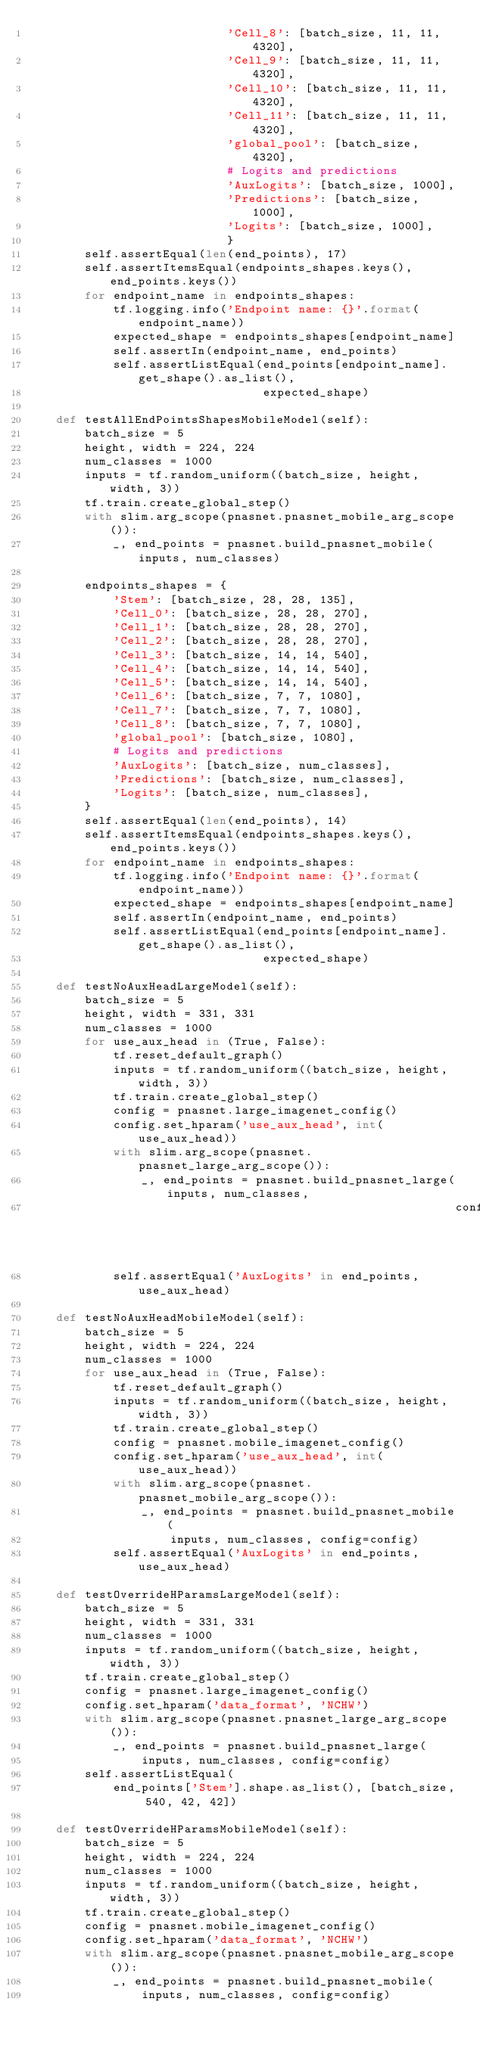Convert code to text. <code><loc_0><loc_0><loc_500><loc_500><_Python_>                            'Cell_8': [batch_size, 11, 11, 4320],
                            'Cell_9': [batch_size, 11, 11, 4320],
                            'Cell_10': [batch_size, 11, 11, 4320],
                            'Cell_11': [batch_size, 11, 11, 4320],
                            'global_pool': [batch_size, 4320],
                            # Logits and predictions
                            'AuxLogits': [batch_size, 1000],
                            'Predictions': [batch_size, 1000],
                            'Logits': [batch_size, 1000],
                            }
        self.assertEqual(len(end_points), 17)
        self.assertItemsEqual(endpoints_shapes.keys(), end_points.keys())
        for endpoint_name in endpoints_shapes:
            tf.logging.info('Endpoint name: {}'.format(endpoint_name))
            expected_shape = endpoints_shapes[endpoint_name]
            self.assertIn(endpoint_name, end_points)
            self.assertListEqual(end_points[endpoint_name].get_shape().as_list(),
                                 expected_shape)

    def testAllEndPointsShapesMobileModel(self):
        batch_size = 5
        height, width = 224, 224
        num_classes = 1000
        inputs = tf.random_uniform((batch_size, height, width, 3))
        tf.train.create_global_step()
        with slim.arg_scope(pnasnet.pnasnet_mobile_arg_scope()):
            _, end_points = pnasnet.build_pnasnet_mobile(inputs, num_classes)

        endpoints_shapes = {
            'Stem': [batch_size, 28, 28, 135],
            'Cell_0': [batch_size, 28, 28, 270],
            'Cell_1': [batch_size, 28, 28, 270],
            'Cell_2': [batch_size, 28, 28, 270],
            'Cell_3': [batch_size, 14, 14, 540],
            'Cell_4': [batch_size, 14, 14, 540],
            'Cell_5': [batch_size, 14, 14, 540],
            'Cell_6': [batch_size, 7, 7, 1080],
            'Cell_7': [batch_size, 7, 7, 1080],
            'Cell_8': [batch_size, 7, 7, 1080],
            'global_pool': [batch_size, 1080],
            # Logits and predictions
            'AuxLogits': [batch_size, num_classes],
            'Predictions': [batch_size, num_classes],
            'Logits': [batch_size, num_classes],
        }
        self.assertEqual(len(end_points), 14)
        self.assertItemsEqual(endpoints_shapes.keys(), end_points.keys())
        for endpoint_name in endpoints_shapes:
            tf.logging.info('Endpoint name: {}'.format(endpoint_name))
            expected_shape = endpoints_shapes[endpoint_name]
            self.assertIn(endpoint_name, end_points)
            self.assertListEqual(end_points[endpoint_name].get_shape().as_list(),
                                 expected_shape)

    def testNoAuxHeadLargeModel(self):
        batch_size = 5
        height, width = 331, 331
        num_classes = 1000
        for use_aux_head in (True, False):
            tf.reset_default_graph()
            inputs = tf.random_uniform((batch_size, height, width, 3))
            tf.train.create_global_step()
            config = pnasnet.large_imagenet_config()
            config.set_hparam('use_aux_head', int(use_aux_head))
            with slim.arg_scope(pnasnet.pnasnet_large_arg_scope()):
                _, end_points = pnasnet.build_pnasnet_large(inputs, num_classes,
                                                            config=config)
            self.assertEqual('AuxLogits' in end_points, use_aux_head)

    def testNoAuxHeadMobileModel(self):
        batch_size = 5
        height, width = 224, 224
        num_classes = 1000
        for use_aux_head in (True, False):
            tf.reset_default_graph()
            inputs = tf.random_uniform((batch_size, height, width, 3))
            tf.train.create_global_step()
            config = pnasnet.mobile_imagenet_config()
            config.set_hparam('use_aux_head', int(use_aux_head))
            with slim.arg_scope(pnasnet.pnasnet_mobile_arg_scope()):
                _, end_points = pnasnet.build_pnasnet_mobile(
                    inputs, num_classes, config=config)
            self.assertEqual('AuxLogits' in end_points, use_aux_head)

    def testOverrideHParamsLargeModel(self):
        batch_size = 5
        height, width = 331, 331
        num_classes = 1000
        inputs = tf.random_uniform((batch_size, height, width, 3))
        tf.train.create_global_step()
        config = pnasnet.large_imagenet_config()
        config.set_hparam('data_format', 'NCHW')
        with slim.arg_scope(pnasnet.pnasnet_large_arg_scope()):
            _, end_points = pnasnet.build_pnasnet_large(
                inputs, num_classes, config=config)
        self.assertListEqual(
            end_points['Stem'].shape.as_list(), [batch_size, 540, 42, 42])

    def testOverrideHParamsMobileModel(self):
        batch_size = 5
        height, width = 224, 224
        num_classes = 1000
        inputs = tf.random_uniform((batch_size, height, width, 3))
        tf.train.create_global_step()
        config = pnasnet.mobile_imagenet_config()
        config.set_hparam('data_format', 'NCHW')
        with slim.arg_scope(pnasnet.pnasnet_mobile_arg_scope()):
            _, end_points = pnasnet.build_pnasnet_mobile(
                inputs, num_classes, config=config)</code> 